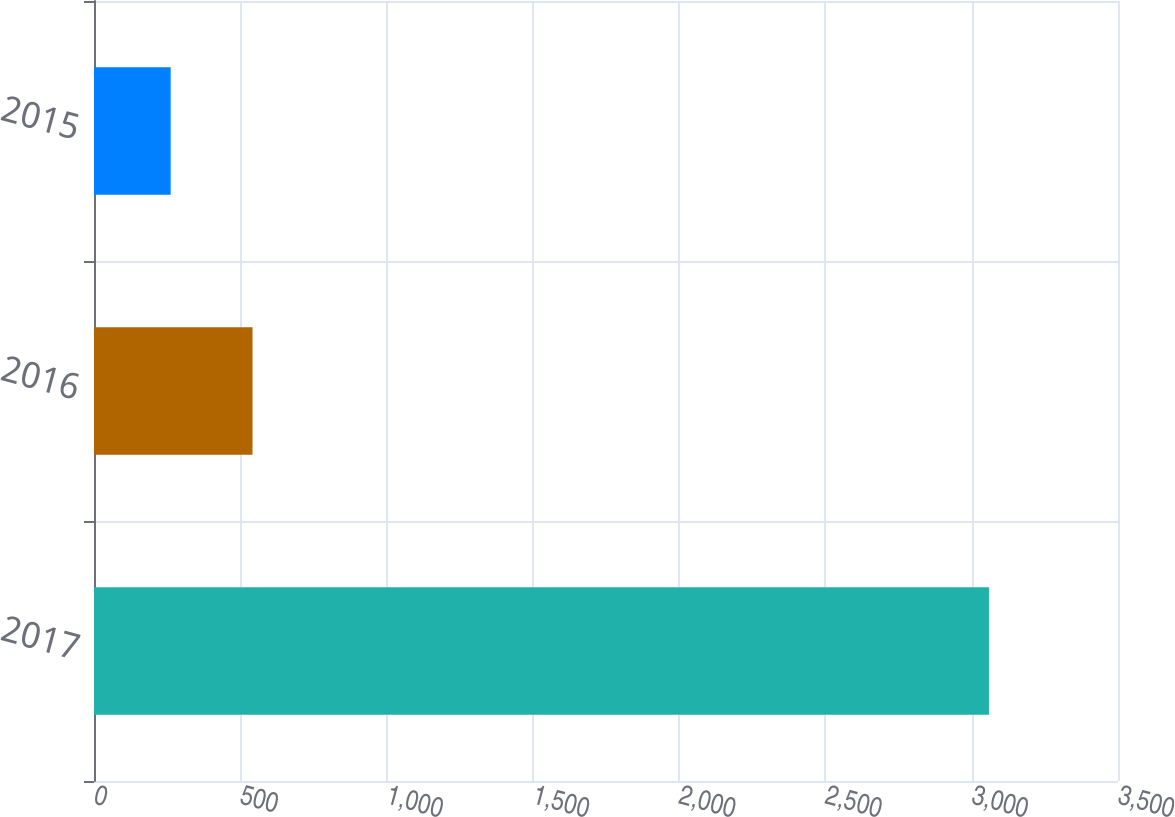Convert chart. <chart><loc_0><loc_0><loc_500><loc_500><bar_chart><fcel>2017<fcel>2016<fcel>2015<nl><fcel>3059<fcel>541.7<fcel>262<nl></chart> 